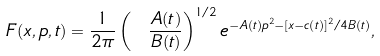Convert formula to latex. <formula><loc_0><loc_0><loc_500><loc_500>F ( x , p , t ) = \frac { 1 } { 2 \pi } \left ( \ \frac { A ( t ) } { B ( t ) } \right ) ^ { 1 / 2 } e ^ { - A ( t ) p ^ { 2 } - [ x - c ( t ) ] ^ { 2 } / 4 B ( t ) } ,</formula> 